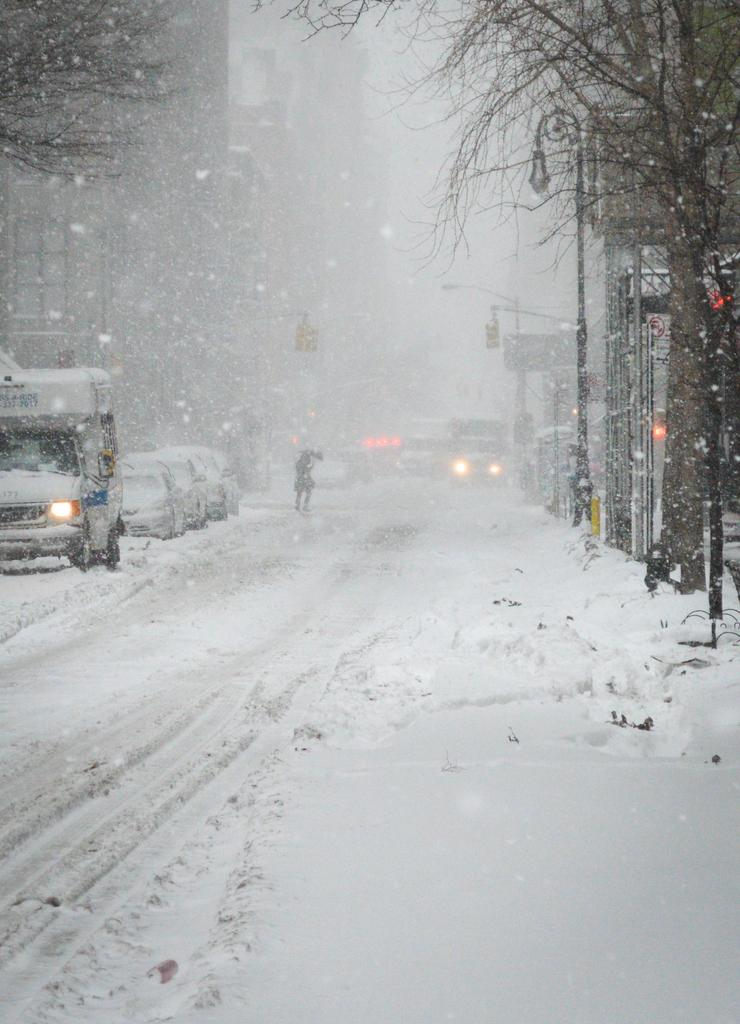What type of natural elements can be seen in the image? There are trees in the image. What type of man-made structures are present in the image? There are buildings in the image. What type of lighting is present in the image? There are street lights in the image. What type of transportation is visible in the image? There are vehicles in the image. Where are the vehicles located in the image? The vehicles are on the road in the image. What is the condition of the road in the image? The road is covered with snow in the image. What type of disease is affecting the trees in the image? There is no indication of any disease affecting the trees in the image. What type of wing is visible on the vehicles in the image? There are no wings visible on the vehicles in the image; they are standard road vehicles. 